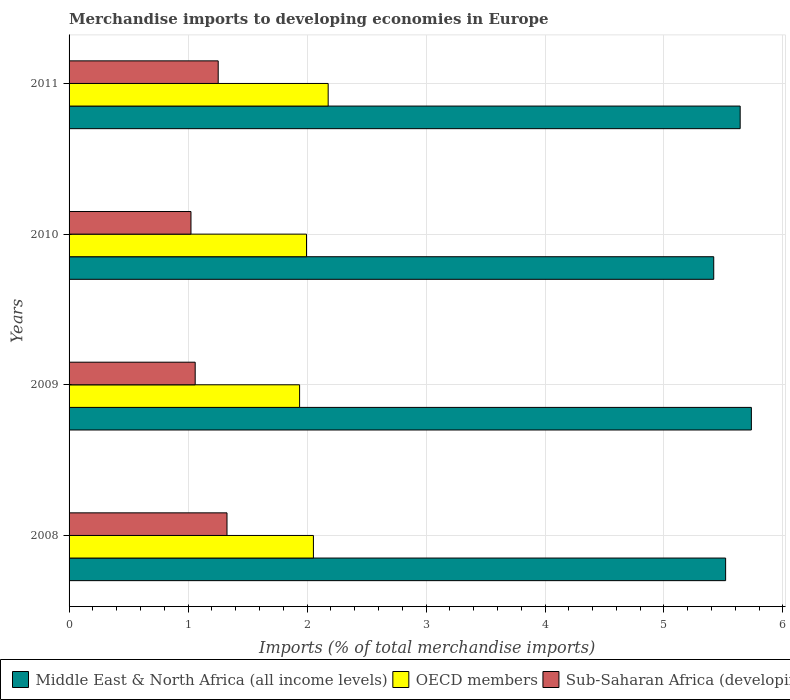How many different coloured bars are there?
Offer a very short reply. 3. Are the number of bars per tick equal to the number of legend labels?
Ensure brevity in your answer.  Yes. Are the number of bars on each tick of the Y-axis equal?
Keep it short and to the point. Yes. How many bars are there on the 4th tick from the bottom?
Offer a terse response. 3. What is the label of the 2nd group of bars from the top?
Offer a very short reply. 2010. What is the percentage total merchandise imports in Sub-Saharan Africa (developing only) in 2009?
Give a very brief answer. 1.06. Across all years, what is the maximum percentage total merchandise imports in OECD members?
Offer a very short reply. 2.18. Across all years, what is the minimum percentage total merchandise imports in Middle East & North Africa (all income levels)?
Your answer should be compact. 5.42. In which year was the percentage total merchandise imports in OECD members maximum?
Make the answer very short. 2011. In which year was the percentage total merchandise imports in Middle East & North Africa (all income levels) minimum?
Give a very brief answer. 2010. What is the total percentage total merchandise imports in Middle East & North Africa (all income levels) in the graph?
Provide a short and direct response. 22.31. What is the difference between the percentage total merchandise imports in Sub-Saharan Africa (developing only) in 2009 and that in 2011?
Provide a short and direct response. -0.19. What is the difference between the percentage total merchandise imports in Middle East & North Africa (all income levels) in 2010 and the percentage total merchandise imports in Sub-Saharan Africa (developing only) in 2008?
Make the answer very short. 4.09. What is the average percentage total merchandise imports in Middle East & North Africa (all income levels) per year?
Ensure brevity in your answer.  5.58. In the year 2009, what is the difference between the percentage total merchandise imports in Middle East & North Africa (all income levels) and percentage total merchandise imports in Sub-Saharan Africa (developing only)?
Your answer should be compact. 4.67. What is the ratio of the percentage total merchandise imports in Sub-Saharan Africa (developing only) in 2008 to that in 2010?
Provide a short and direct response. 1.3. What is the difference between the highest and the second highest percentage total merchandise imports in OECD members?
Make the answer very short. 0.12. What is the difference between the highest and the lowest percentage total merchandise imports in Middle East & North Africa (all income levels)?
Give a very brief answer. 0.32. In how many years, is the percentage total merchandise imports in Middle East & North Africa (all income levels) greater than the average percentage total merchandise imports in Middle East & North Africa (all income levels) taken over all years?
Provide a short and direct response. 2. What does the 3rd bar from the top in 2010 represents?
Your response must be concise. Middle East & North Africa (all income levels). Is it the case that in every year, the sum of the percentage total merchandise imports in OECD members and percentage total merchandise imports in Middle East & North Africa (all income levels) is greater than the percentage total merchandise imports in Sub-Saharan Africa (developing only)?
Ensure brevity in your answer.  Yes. How many bars are there?
Keep it short and to the point. 12. Are all the bars in the graph horizontal?
Make the answer very short. Yes. What is the difference between two consecutive major ticks on the X-axis?
Offer a terse response. 1. Are the values on the major ticks of X-axis written in scientific E-notation?
Ensure brevity in your answer.  No. How many legend labels are there?
Ensure brevity in your answer.  3. How are the legend labels stacked?
Offer a very short reply. Horizontal. What is the title of the graph?
Keep it short and to the point. Merchandise imports to developing economies in Europe. What is the label or title of the X-axis?
Your answer should be compact. Imports (% of total merchandise imports). What is the label or title of the Y-axis?
Ensure brevity in your answer.  Years. What is the Imports (% of total merchandise imports) of Middle East & North Africa (all income levels) in 2008?
Ensure brevity in your answer.  5.52. What is the Imports (% of total merchandise imports) of OECD members in 2008?
Your answer should be very brief. 2.05. What is the Imports (% of total merchandise imports) in Sub-Saharan Africa (developing only) in 2008?
Your response must be concise. 1.33. What is the Imports (% of total merchandise imports) of Middle East & North Africa (all income levels) in 2009?
Provide a short and direct response. 5.73. What is the Imports (% of total merchandise imports) of OECD members in 2009?
Keep it short and to the point. 1.94. What is the Imports (% of total merchandise imports) in Sub-Saharan Africa (developing only) in 2009?
Provide a succinct answer. 1.06. What is the Imports (% of total merchandise imports) of Middle East & North Africa (all income levels) in 2010?
Your answer should be compact. 5.42. What is the Imports (% of total merchandise imports) of OECD members in 2010?
Make the answer very short. 2. What is the Imports (% of total merchandise imports) of Sub-Saharan Africa (developing only) in 2010?
Give a very brief answer. 1.02. What is the Imports (% of total merchandise imports) of Middle East & North Africa (all income levels) in 2011?
Your response must be concise. 5.64. What is the Imports (% of total merchandise imports) in OECD members in 2011?
Keep it short and to the point. 2.18. What is the Imports (% of total merchandise imports) of Sub-Saharan Africa (developing only) in 2011?
Your answer should be very brief. 1.25. Across all years, what is the maximum Imports (% of total merchandise imports) of Middle East & North Africa (all income levels)?
Provide a succinct answer. 5.73. Across all years, what is the maximum Imports (% of total merchandise imports) of OECD members?
Offer a terse response. 2.18. Across all years, what is the maximum Imports (% of total merchandise imports) in Sub-Saharan Africa (developing only)?
Provide a short and direct response. 1.33. Across all years, what is the minimum Imports (% of total merchandise imports) of Middle East & North Africa (all income levels)?
Keep it short and to the point. 5.42. Across all years, what is the minimum Imports (% of total merchandise imports) in OECD members?
Provide a short and direct response. 1.94. Across all years, what is the minimum Imports (% of total merchandise imports) in Sub-Saharan Africa (developing only)?
Make the answer very short. 1.02. What is the total Imports (% of total merchandise imports) of Middle East & North Africa (all income levels) in the graph?
Give a very brief answer. 22.31. What is the total Imports (% of total merchandise imports) of OECD members in the graph?
Offer a very short reply. 8.16. What is the total Imports (% of total merchandise imports) of Sub-Saharan Africa (developing only) in the graph?
Ensure brevity in your answer.  4.67. What is the difference between the Imports (% of total merchandise imports) in Middle East & North Africa (all income levels) in 2008 and that in 2009?
Give a very brief answer. -0.22. What is the difference between the Imports (% of total merchandise imports) of OECD members in 2008 and that in 2009?
Your answer should be compact. 0.12. What is the difference between the Imports (% of total merchandise imports) in Sub-Saharan Africa (developing only) in 2008 and that in 2009?
Make the answer very short. 0.27. What is the difference between the Imports (% of total merchandise imports) of Middle East & North Africa (all income levels) in 2008 and that in 2010?
Your answer should be very brief. 0.1. What is the difference between the Imports (% of total merchandise imports) in OECD members in 2008 and that in 2010?
Your answer should be very brief. 0.06. What is the difference between the Imports (% of total merchandise imports) in Sub-Saharan Africa (developing only) in 2008 and that in 2010?
Your response must be concise. 0.3. What is the difference between the Imports (% of total merchandise imports) of Middle East & North Africa (all income levels) in 2008 and that in 2011?
Your answer should be very brief. -0.12. What is the difference between the Imports (% of total merchandise imports) in OECD members in 2008 and that in 2011?
Offer a terse response. -0.12. What is the difference between the Imports (% of total merchandise imports) in Sub-Saharan Africa (developing only) in 2008 and that in 2011?
Provide a short and direct response. 0.07. What is the difference between the Imports (% of total merchandise imports) of Middle East & North Africa (all income levels) in 2009 and that in 2010?
Your answer should be compact. 0.32. What is the difference between the Imports (% of total merchandise imports) in OECD members in 2009 and that in 2010?
Your response must be concise. -0.06. What is the difference between the Imports (% of total merchandise imports) in Sub-Saharan Africa (developing only) in 2009 and that in 2010?
Offer a terse response. 0.04. What is the difference between the Imports (% of total merchandise imports) in Middle East & North Africa (all income levels) in 2009 and that in 2011?
Your answer should be very brief. 0.09. What is the difference between the Imports (% of total merchandise imports) of OECD members in 2009 and that in 2011?
Your answer should be compact. -0.24. What is the difference between the Imports (% of total merchandise imports) of Sub-Saharan Africa (developing only) in 2009 and that in 2011?
Give a very brief answer. -0.19. What is the difference between the Imports (% of total merchandise imports) in Middle East & North Africa (all income levels) in 2010 and that in 2011?
Offer a very short reply. -0.22. What is the difference between the Imports (% of total merchandise imports) of OECD members in 2010 and that in 2011?
Provide a succinct answer. -0.18. What is the difference between the Imports (% of total merchandise imports) of Sub-Saharan Africa (developing only) in 2010 and that in 2011?
Provide a succinct answer. -0.23. What is the difference between the Imports (% of total merchandise imports) of Middle East & North Africa (all income levels) in 2008 and the Imports (% of total merchandise imports) of OECD members in 2009?
Give a very brief answer. 3.58. What is the difference between the Imports (% of total merchandise imports) of Middle East & North Africa (all income levels) in 2008 and the Imports (% of total merchandise imports) of Sub-Saharan Africa (developing only) in 2009?
Offer a very short reply. 4.46. What is the difference between the Imports (% of total merchandise imports) in OECD members in 2008 and the Imports (% of total merchandise imports) in Sub-Saharan Africa (developing only) in 2009?
Make the answer very short. 0.99. What is the difference between the Imports (% of total merchandise imports) in Middle East & North Africa (all income levels) in 2008 and the Imports (% of total merchandise imports) in OECD members in 2010?
Provide a short and direct response. 3.52. What is the difference between the Imports (% of total merchandise imports) in Middle East & North Africa (all income levels) in 2008 and the Imports (% of total merchandise imports) in Sub-Saharan Africa (developing only) in 2010?
Your answer should be very brief. 4.49. What is the difference between the Imports (% of total merchandise imports) of OECD members in 2008 and the Imports (% of total merchandise imports) of Sub-Saharan Africa (developing only) in 2010?
Provide a succinct answer. 1.03. What is the difference between the Imports (% of total merchandise imports) in Middle East & North Africa (all income levels) in 2008 and the Imports (% of total merchandise imports) in OECD members in 2011?
Make the answer very short. 3.34. What is the difference between the Imports (% of total merchandise imports) of Middle East & North Africa (all income levels) in 2008 and the Imports (% of total merchandise imports) of Sub-Saharan Africa (developing only) in 2011?
Ensure brevity in your answer.  4.26. What is the difference between the Imports (% of total merchandise imports) of OECD members in 2008 and the Imports (% of total merchandise imports) of Sub-Saharan Africa (developing only) in 2011?
Offer a terse response. 0.8. What is the difference between the Imports (% of total merchandise imports) of Middle East & North Africa (all income levels) in 2009 and the Imports (% of total merchandise imports) of OECD members in 2010?
Provide a short and direct response. 3.74. What is the difference between the Imports (% of total merchandise imports) in Middle East & North Africa (all income levels) in 2009 and the Imports (% of total merchandise imports) in Sub-Saharan Africa (developing only) in 2010?
Provide a short and direct response. 4.71. What is the difference between the Imports (% of total merchandise imports) in OECD members in 2009 and the Imports (% of total merchandise imports) in Sub-Saharan Africa (developing only) in 2010?
Your response must be concise. 0.91. What is the difference between the Imports (% of total merchandise imports) of Middle East & North Africa (all income levels) in 2009 and the Imports (% of total merchandise imports) of OECD members in 2011?
Your answer should be very brief. 3.56. What is the difference between the Imports (% of total merchandise imports) of Middle East & North Africa (all income levels) in 2009 and the Imports (% of total merchandise imports) of Sub-Saharan Africa (developing only) in 2011?
Offer a very short reply. 4.48. What is the difference between the Imports (% of total merchandise imports) in OECD members in 2009 and the Imports (% of total merchandise imports) in Sub-Saharan Africa (developing only) in 2011?
Give a very brief answer. 0.68. What is the difference between the Imports (% of total merchandise imports) of Middle East & North Africa (all income levels) in 2010 and the Imports (% of total merchandise imports) of OECD members in 2011?
Offer a very short reply. 3.24. What is the difference between the Imports (% of total merchandise imports) in Middle East & North Africa (all income levels) in 2010 and the Imports (% of total merchandise imports) in Sub-Saharan Africa (developing only) in 2011?
Your response must be concise. 4.16. What is the difference between the Imports (% of total merchandise imports) of OECD members in 2010 and the Imports (% of total merchandise imports) of Sub-Saharan Africa (developing only) in 2011?
Offer a very short reply. 0.74. What is the average Imports (% of total merchandise imports) in Middle East & North Africa (all income levels) per year?
Ensure brevity in your answer.  5.58. What is the average Imports (% of total merchandise imports) of OECD members per year?
Your answer should be compact. 2.04. What is the average Imports (% of total merchandise imports) of Sub-Saharan Africa (developing only) per year?
Your response must be concise. 1.17. In the year 2008, what is the difference between the Imports (% of total merchandise imports) in Middle East & North Africa (all income levels) and Imports (% of total merchandise imports) in OECD members?
Your answer should be very brief. 3.46. In the year 2008, what is the difference between the Imports (% of total merchandise imports) of Middle East & North Africa (all income levels) and Imports (% of total merchandise imports) of Sub-Saharan Africa (developing only)?
Provide a succinct answer. 4.19. In the year 2008, what is the difference between the Imports (% of total merchandise imports) of OECD members and Imports (% of total merchandise imports) of Sub-Saharan Africa (developing only)?
Provide a succinct answer. 0.73. In the year 2009, what is the difference between the Imports (% of total merchandise imports) of Middle East & North Africa (all income levels) and Imports (% of total merchandise imports) of OECD members?
Provide a succinct answer. 3.8. In the year 2009, what is the difference between the Imports (% of total merchandise imports) in Middle East & North Africa (all income levels) and Imports (% of total merchandise imports) in Sub-Saharan Africa (developing only)?
Keep it short and to the point. 4.67. In the year 2009, what is the difference between the Imports (% of total merchandise imports) in OECD members and Imports (% of total merchandise imports) in Sub-Saharan Africa (developing only)?
Provide a succinct answer. 0.88. In the year 2010, what is the difference between the Imports (% of total merchandise imports) of Middle East & North Africa (all income levels) and Imports (% of total merchandise imports) of OECD members?
Provide a short and direct response. 3.42. In the year 2010, what is the difference between the Imports (% of total merchandise imports) in Middle East & North Africa (all income levels) and Imports (% of total merchandise imports) in Sub-Saharan Africa (developing only)?
Make the answer very short. 4.39. In the year 2010, what is the difference between the Imports (% of total merchandise imports) in OECD members and Imports (% of total merchandise imports) in Sub-Saharan Africa (developing only)?
Your answer should be compact. 0.97. In the year 2011, what is the difference between the Imports (% of total merchandise imports) in Middle East & North Africa (all income levels) and Imports (% of total merchandise imports) in OECD members?
Your response must be concise. 3.46. In the year 2011, what is the difference between the Imports (% of total merchandise imports) in Middle East & North Africa (all income levels) and Imports (% of total merchandise imports) in Sub-Saharan Africa (developing only)?
Keep it short and to the point. 4.39. In the year 2011, what is the difference between the Imports (% of total merchandise imports) of OECD members and Imports (% of total merchandise imports) of Sub-Saharan Africa (developing only)?
Make the answer very short. 0.92. What is the ratio of the Imports (% of total merchandise imports) of Middle East & North Africa (all income levels) in 2008 to that in 2009?
Offer a terse response. 0.96. What is the ratio of the Imports (% of total merchandise imports) of OECD members in 2008 to that in 2009?
Make the answer very short. 1.06. What is the ratio of the Imports (% of total merchandise imports) in Sub-Saharan Africa (developing only) in 2008 to that in 2009?
Make the answer very short. 1.25. What is the ratio of the Imports (% of total merchandise imports) of Middle East & North Africa (all income levels) in 2008 to that in 2010?
Offer a very short reply. 1.02. What is the ratio of the Imports (% of total merchandise imports) of OECD members in 2008 to that in 2010?
Your response must be concise. 1.03. What is the ratio of the Imports (% of total merchandise imports) in Sub-Saharan Africa (developing only) in 2008 to that in 2010?
Keep it short and to the point. 1.3. What is the ratio of the Imports (% of total merchandise imports) of Middle East & North Africa (all income levels) in 2008 to that in 2011?
Ensure brevity in your answer.  0.98. What is the ratio of the Imports (% of total merchandise imports) of OECD members in 2008 to that in 2011?
Make the answer very short. 0.94. What is the ratio of the Imports (% of total merchandise imports) in Sub-Saharan Africa (developing only) in 2008 to that in 2011?
Ensure brevity in your answer.  1.06. What is the ratio of the Imports (% of total merchandise imports) of Middle East & North Africa (all income levels) in 2009 to that in 2010?
Make the answer very short. 1.06. What is the ratio of the Imports (% of total merchandise imports) of OECD members in 2009 to that in 2010?
Offer a very short reply. 0.97. What is the ratio of the Imports (% of total merchandise imports) in Sub-Saharan Africa (developing only) in 2009 to that in 2010?
Your answer should be very brief. 1.03. What is the ratio of the Imports (% of total merchandise imports) of Middle East & North Africa (all income levels) in 2009 to that in 2011?
Offer a terse response. 1.02. What is the ratio of the Imports (% of total merchandise imports) of OECD members in 2009 to that in 2011?
Provide a short and direct response. 0.89. What is the ratio of the Imports (% of total merchandise imports) in Sub-Saharan Africa (developing only) in 2009 to that in 2011?
Ensure brevity in your answer.  0.85. What is the ratio of the Imports (% of total merchandise imports) of Middle East & North Africa (all income levels) in 2010 to that in 2011?
Provide a succinct answer. 0.96. What is the ratio of the Imports (% of total merchandise imports) in OECD members in 2010 to that in 2011?
Make the answer very short. 0.92. What is the ratio of the Imports (% of total merchandise imports) of Sub-Saharan Africa (developing only) in 2010 to that in 2011?
Provide a succinct answer. 0.82. What is the difference between the highest and the second highest Imports (% of total merchandise imports) in Middle East & North Africa (all income levels)?
Offer a terse response. 0.09. What is the difference between the highest and the second highest Imports (% of total merchandise imports) of OECD members?
Offer a very short reply. 0.12. What is the difference between the highest and the second highest Imports (% of total merchandise imports) in Sub-Saharan Africa (developing only)?
Provide a short and direct response. 0.07. What is the difference between the highest and the lowest Imports (% of total merchandise imports) of Middle East & North Africa (all income levels)?
Provide a short and direct response. 0.32. What is the difference between the highest and the lowest Imports (% of total merchandise imports) in OECD members?
Your answer should be compact. 0.24. What is the difference between the highest and the lowest Imports (% of total merchandise imports) in Sub-Saharan Africa (developing only)?
Your response must be concise. 0.3. 